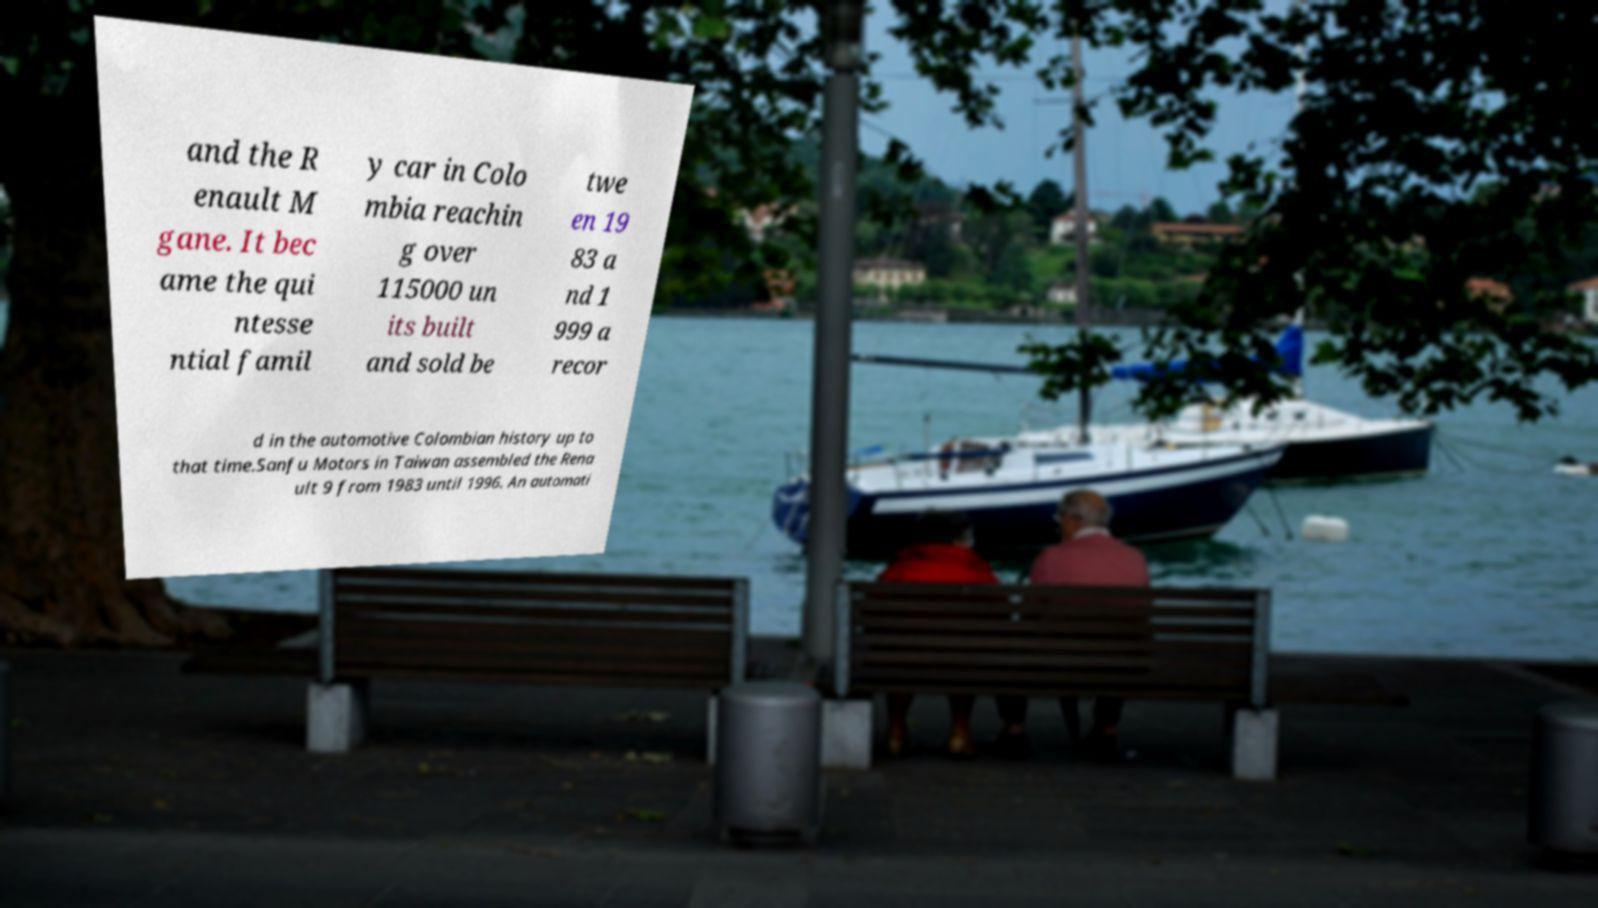Could you extract and type out the text from this image? and the R enault M gane. It bec ame the qui ntesse ntial famil y car in Colo mbia reachin g over 115000 un its built and sold be twe en 19 83 a nd 1 999 a recor d in the automotive Colombian history up to that time.Sanfu Motors in Taiwan assembled the Rena ult 9 from 1983 until 1996. An automati 